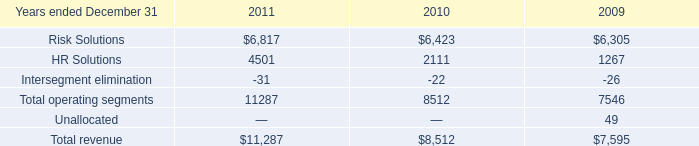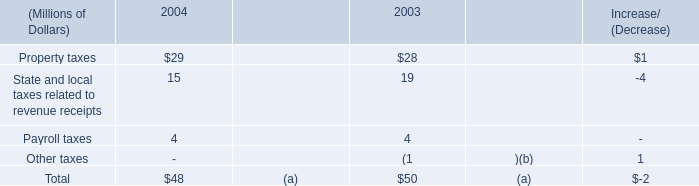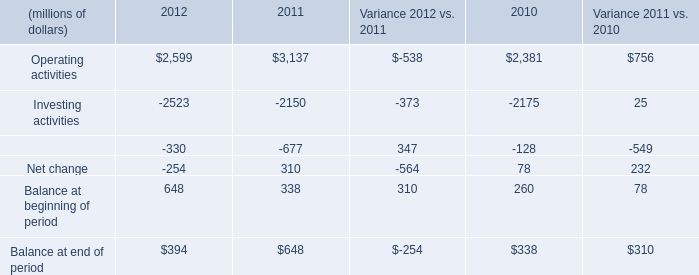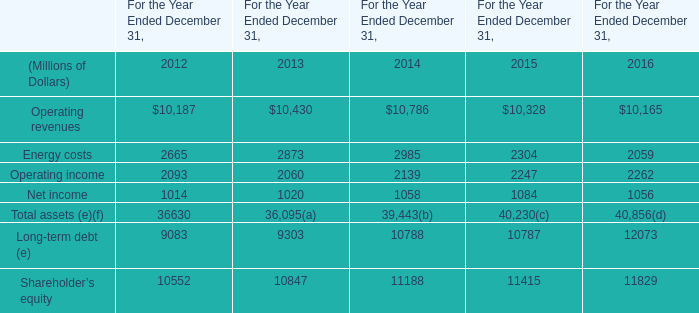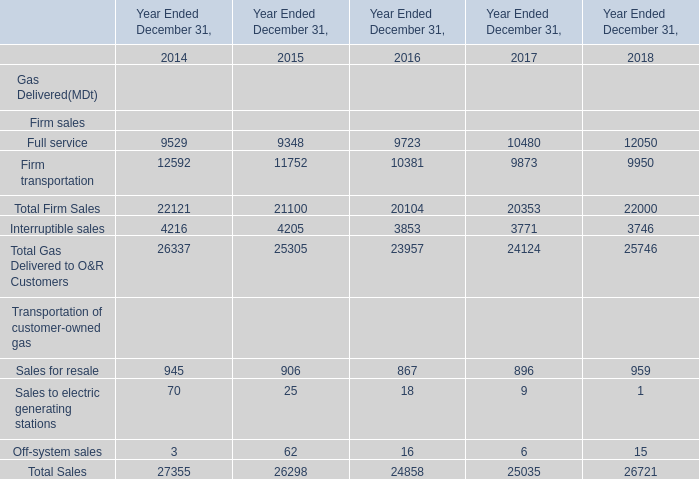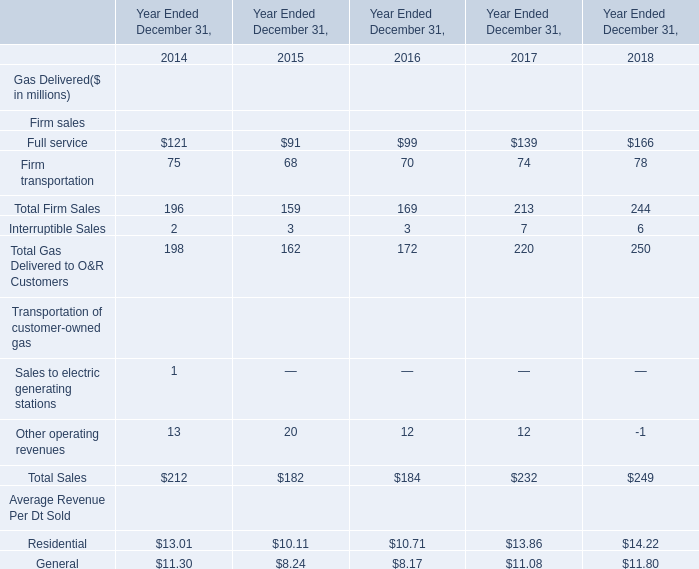What's the total value of all elements that are smaller than 100 in 2015? (in million) 
Computations: (((((91 + 68) + 3) + 20) + 10.11) + 8.24)
Answer: 200.35. 